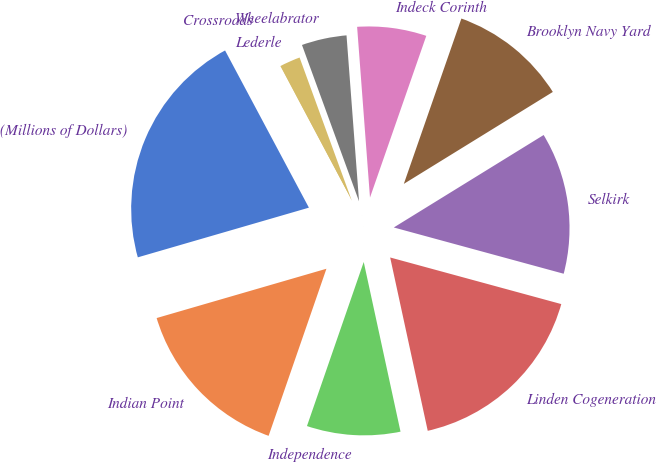Convert chart to OTSL. <chart><loc_0><loc_0><loc_500><loc_500><pie_chart><fcel>(Millions of Dollars)<fcel>Indian Point<fcel>Independence<fcel>Linden Cogeneration<fcel>Selkirk<fcel>Brooklyn Navy Yard<fcel>Indeck Corinth<fcel>Wheelabrator<fcel>Lederle<fcel>Crossroads<nl><fcel>21.7%<fcel>15.2%<fcel>8.7%<fcel>17.37%<fcel>13.03%<fcel>10.87%<fcel>6.53%<fcel>4.37%<fcel>2.2%<fcel>0.03%<nl></chart> 